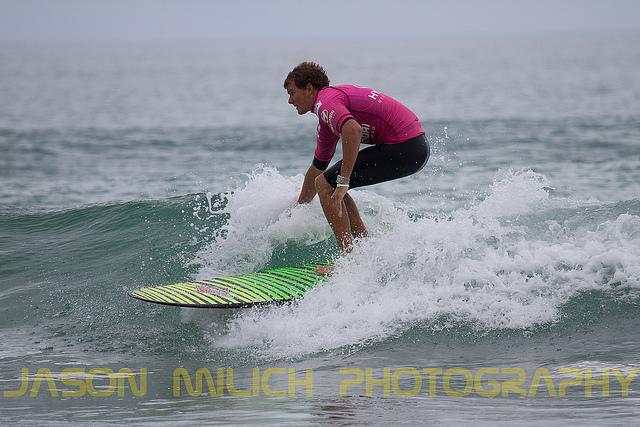What color are his shorts?
Be succinct. Black. What color is the board?
Keep it brief. Green and black. What pattern is on the surfboard?
Short answer required. Stripes. Is the man wearing a watch?
Short answer required. Yes. 